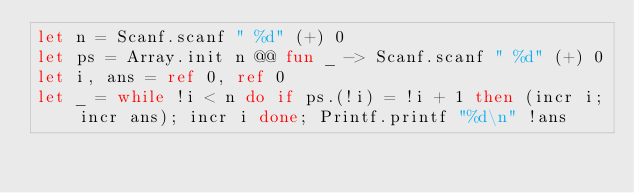<code> <loc_0><loc_0><loc_500><loc_500><_OCaml_>let n = Scanf.scanf " %d" (+) 0
let ps = Array.init n @@ fun _ -> Scanf.scanf " %d" (+) 0
let i, ans = ref 0, ref 0
let _ = while !i < n do if ps.(!i) = !i + 1 then (incr i; incr ans); incr i done; Printf.printf "%d\n" !ans</code> 